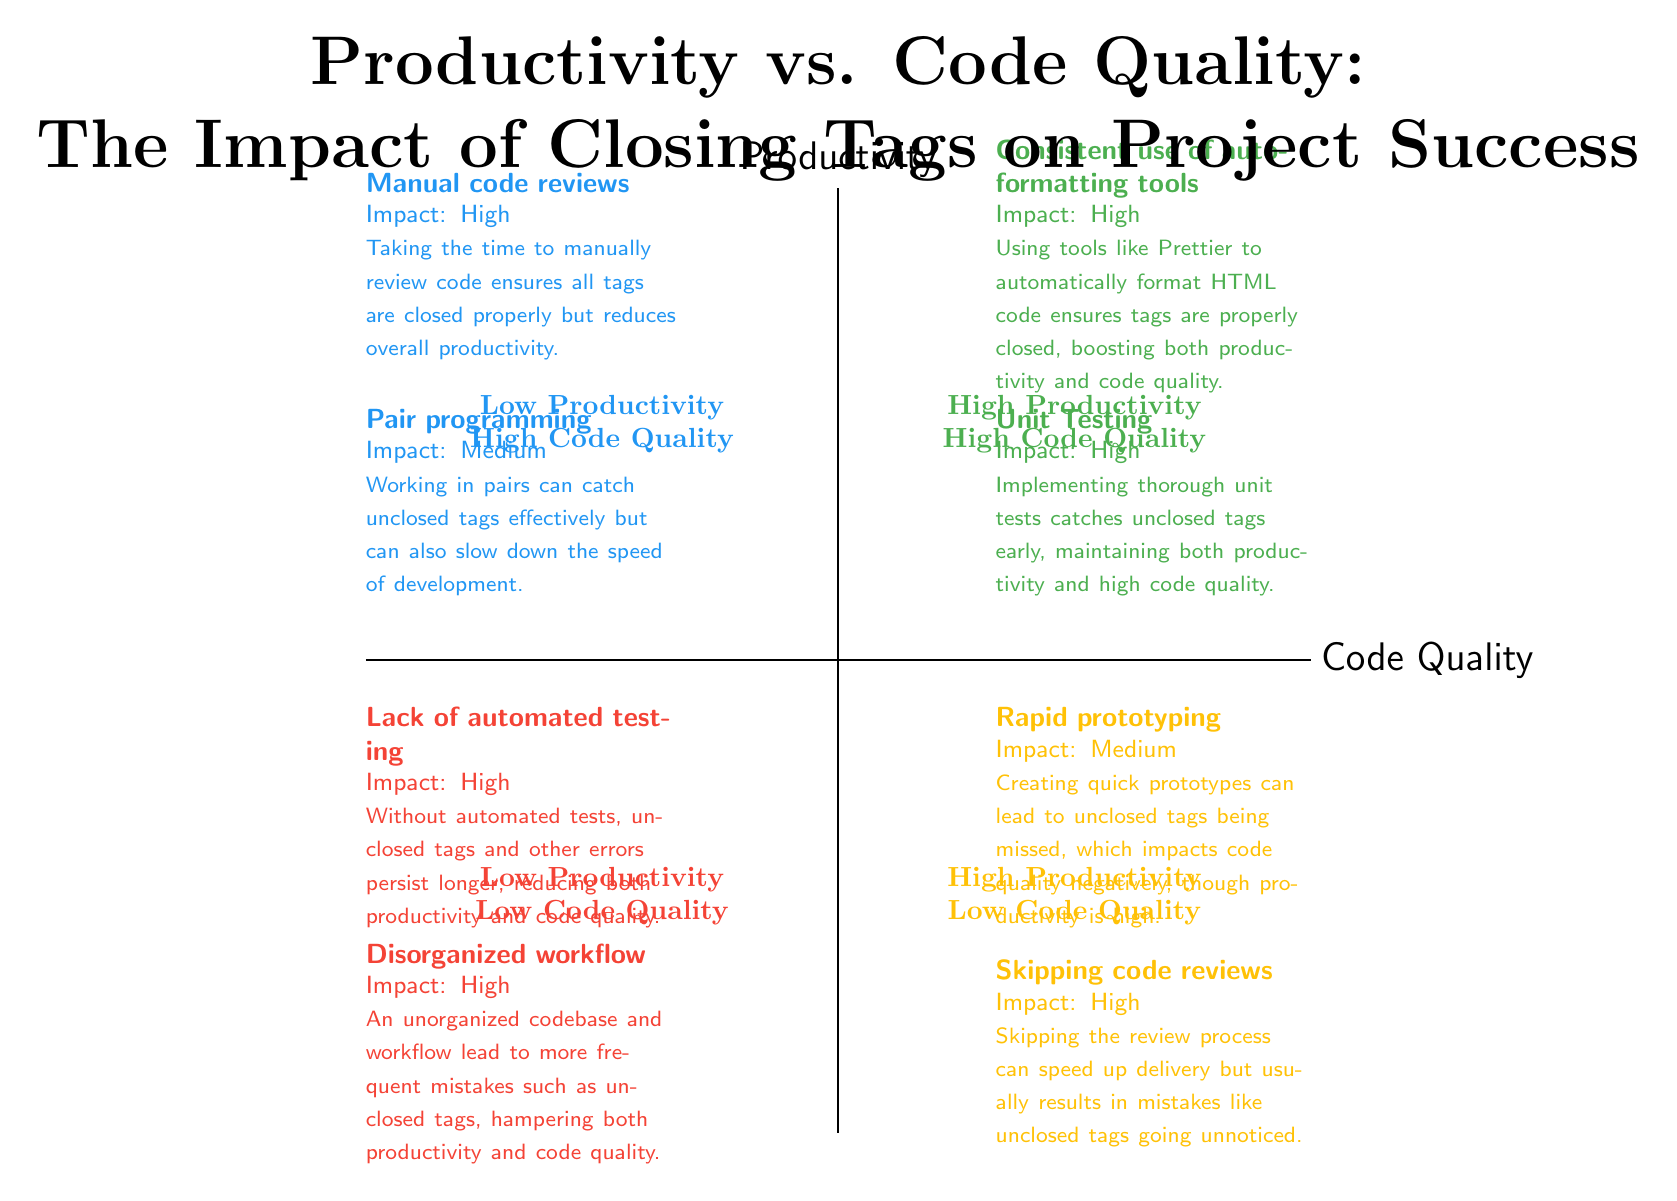What are the two elements in the High Productivity / High Code Quality quadrant? According to the diagram, the elements in this quadrant are "Consistent use of auto-formatting tools" and "Unit Testing." These elements together indicate practices that boost both productivity and code quality.
Answer: Consistent use of auto-formatting tools, Unit Testing What impact does skipping code reviews have on code quality? The diagram states that skipping code reviews results in mistakes like unclosed tags going unnoticed, which negatively affects code quality. Therefore, the impact is categorized as high.
Answer: High Which quadrant features pair programming? Pair programming is listed under the Low Productivity / High Code Quality quadrant. This quadrant indicates that while code quality may be enhanced by such collaborative practices, productivity is typically reduced.
Answer: Low Productivity / High Code Quality How many elements are identified in the Low Productivity / Low Code Quality quadrant? The diagram specifies two elements in this quadrant: "Lack of automated testing" and "Disorganized workflow." Both contribute to decreased productivity and lower code quality.
Answer: Two In which quadrant is "Manual code reviews" positioned, and what impact is described? "Manual code reviews" are placed in the Low Productivity / High Code Quality quadrant. The impact is described as high, emphasizing that thorough reviews enhance code quality at the expense of productivity.
Answer: Low Productivity / High Code Quality, High What is a common risk associated with rapid prototyping, as depicted in the diagram? The diagram highlights that rapid prototyping can lead to unclosed tags being missed; thus, while productivity is high, code quality may suffer significantly, leading to errors.
Answer: Unclosed tags missed How does the presence of automated testing affect productivity and code quality? The diagram indicates that a lack of automated testing leads to errors persisting longer, such as unclosed tags, adversely affecting both productivity and code quality. Therefore, automated testing is crucial for maintaining both aspects.
Answer: Both decrease Which practices can lead to High Productivity but Low Code Quality? The diagram lists two practices: "Rapid prototyping" and "Skipping code reviews," both of which can enhance productivity but at the cost of lower code quality due to oversight of errors such as unclosed tags.
Answer: Rapid prototyping, Skipping code reviews What is the overall effect of disorganization on project outcomes, based on the diagram? The diagram states that a disorganized workflow leads to frequent mistakes such as unclosed tags, negatively impacting both productivity and code quality. Therefore, organization is vital for successful project management.
Answer: Negative impact on both 